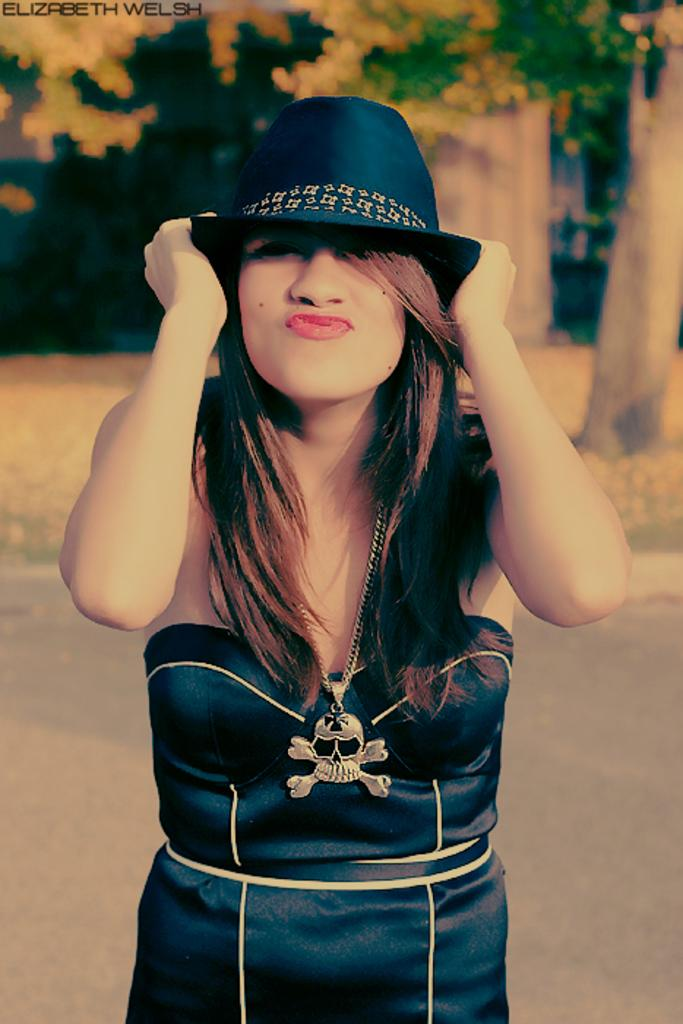Who is the main subject in the image? There is a woman in the image. What is the woman wearing? The woman is wearing clothes, a neck chain, and a hat. Can you describe the background of the image? The background of the image is blurred. What type of property can be seen in the background of the image? There is no property visible in the background of the image; it is blurred. Is there a carriage present in the image? There is no carriage present in the image. 